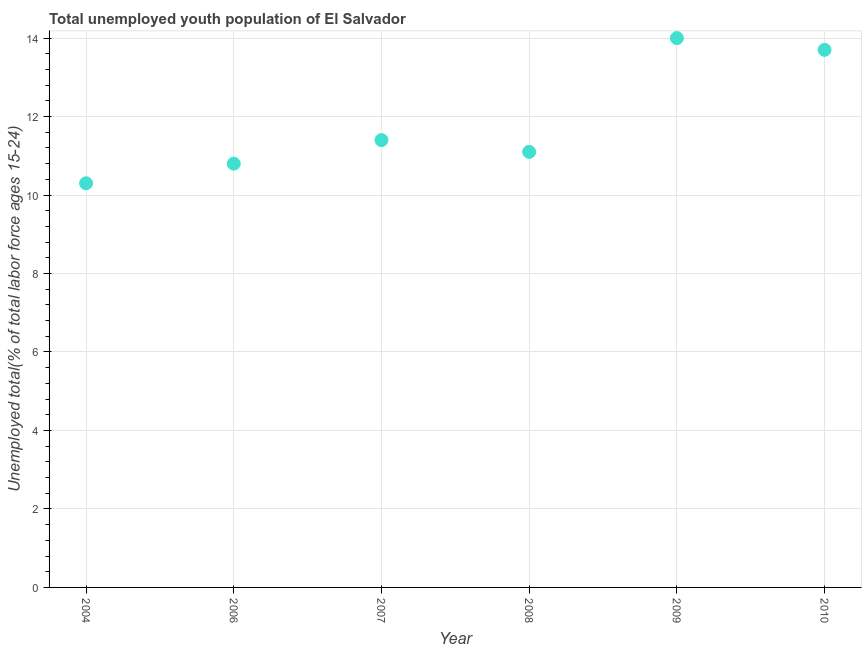What is the unemployed youth in 2007?
Offer a terse response. 11.4. Across all years, what is the maximum unemployed youth?
Offer a terse response. 14. Across all years, what is the minimum unemployed youth?
Provide a short and direct response. 10.3. In which year was the unemployed youth maximum?
Ensure brevity in your answer.  2009. What is the sum of the unemployed youth?
Your answer should be very brief. 71.3. What is the difference between the unemployed youth in 2004 and 2006?
Offer a terse response. -0.5. What is the average unemployed youth per year?
Give a very brief answer. 11.88. What is the median unemployed youth?
Your answer should be very brief. 11.25. In how many years, is the unemployed youth greater than 4 %?
Provide a succinct answer. 6. What is the ratio of the unemployed youth in 2009 to that in 2010?
Make the answer very short. 1.02. What is the difference between the highest and the second highest unemployed youth?
Keep it short and to the point. 0.3. Is the sum of the unemployed youth in 2006 and 2008 greater than the maximum unemployed youth across all years?
Offer a very short reply. Yes. What is the difference between the highest and the lowest unemployed youth?
Ensure brevity in your answer.  3.7. Does the unemployed youth monotonically increase over the years?
Make the answer very short. No. How many dotlines are there?
Your answer should be compact. 1. Does the graph contain grids?
Offer a terse response. Yes. What is the title of the graph?
Your answer should be very brief. Total unemployed youth population of El Salvador. What is the label or title of the Y-axis?
Keep it short and to the point. Unemployed total(% of total labor force ages 15-24). What is the Unemployed total(% of total labor force ages 15-24) in 2004?
Provide a succinct answer. 10.3. What is the Unemployed total(% of total labor force ages 15-24) in 2006?
Offer a terse response. 10.8. What is the Unemployed total(% of total labor force ages 15-24) in 2007?
Your response must be concise. 11.4. What is the Unemployed total(% of total labor force ages 15-24) in 2008?
Provide a succinct answer. 11.1. What is the Unemployed total(% of total labor force ages 15-24) in 2009?
Ensure brevity in your answer.  14. What is the Unemployed total(% of total labor force ages 15-24) in 2010?
Your response must be concise. 13.7. What is the difference between the Unemployed total(% of total labor force ages 15-24) in 2004 and 2009?
Give a very brief answer. -3.7. What is the difference between the Unemployed total(% of total labor force ages 15-24) in 2006 and 2007?
Provide a short and direct response. -0.6. What is the difference between the Unemployed total(% of total labor force ages 15-24) in 2006 and 2008?
Provide a short and direct response. -0.3. What is the difference between the Unemployed total(% of total labor force ages 15-24) in 2006 and 2009?
Keep it short and to the point. -3.2. What is the difference between the Unemployed total(% of total labor force ages 15-24) in 2007 and 2008?
Provide a succinct answer. 0.3. What is the difference between the Unemployed total(% of total labor force ages 15-24) in 2007 and 2009?
Make the answer very short. -2.6. What is the difference between the Unemployed total(% of total labor force ages 15-24) in 2007 and 2010?
Provide a succinct answer. -2.3. What is the difference between the Unemployed total(% of total labor force ages 15-24) in 2009 and 2010?
Provide a short and direct response. 0.3. What is the ratio of the Unemployed total(% of total labor force ages 15-24) in 2004 to that in 2006?
Your response must be concise. 0.95. What is the ratio of the Unemployed total(% of total labor force ages 15-24) in 2004 to that in 2007?
Ensure brevity in your answer.  0.9. What is the ratio of the Unemployed total(% of total labor force ages 15-24) in 2004 to that in 2008?
Keep it short and to the point. 0.93. What is the ratio of the Unemployed total(% of total labor force ages 15-24) in 2004 to that in 2009?
Your answer should be compact. 0.74. What is the ratio of the Unemployed total(% of total labor force ages 15-24) in 2004 to that in 2010?
Offer a terse response. 0.75. What is the ratio of the Unemployed total(% of total labor force ages 15-24) in 2006 to that in 2007?
Offer a terse response. 0.95. What is the ratio of the Unemployed total(% of total labor force ages 15-24) in 2006 to that in 2009?
Your answer should be compact. 0.77. What is the ratio of the Unemployed total(% of total labor force ages 15-24) in 2006 to that in 2010?
Your response must be concise. 0.79. What is the ratio of the Unemployed total(% of total labor force ages 15-24) in 2007 to that in 2008?
Provide a succinct answer. 1.03. What is the ratio of the Unemployed total(% of total labor force ages 15-24) in 2007 to that in 2009?
Ensure brevity in your answer.  0.81. What is the ratio of the Unemployed total(% of total labor force ages 15-24) in 2007 to that in 2010?
Offer a very short reply. 0.83. What is the ratio of the Unemployed total(% of total labor force ages 15-24) in 2008 to that in 2009?
Offer a terse response. 0.79. What is the ratio of the Unemployed total(% of total labor force ages 15-24) in 2008 to that in 2010?
Keep it short and to the point. 0.81. What is the ratio of the Unemployed total(% of total labor force ages 15-24) in 2009 to that in 2010?
Your response must be concise. 1.02. 